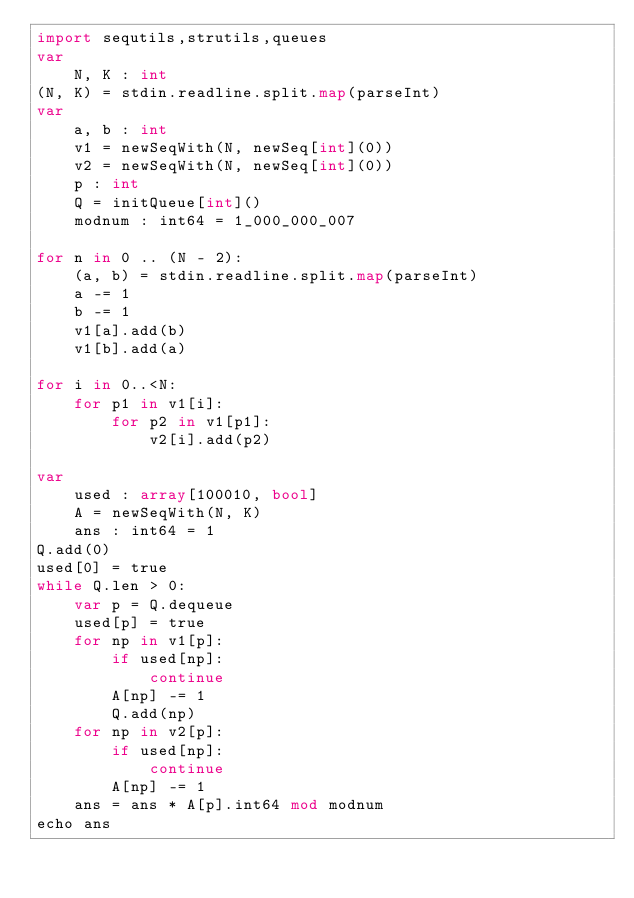Convert code to text. <code><loc_0><loc_0><loc_500><loc_500><_Nim_>import sequtils,strutils,queues
var
    N, K : int
(N, K) = stdin.readline.split.map(parseInt)
var
    a, b : int
    v1 = newSeqWith(N, newSeq[int](0))
    v2 = newSeqWith(N, newSeq[int](0))
    p : int
    Q = initQueue[int]()
    modnum : int64 = 1_000_000_007

for n in 0 .. (N - 2):
    (a, b) = stdin.readline.split.map(parseInt)
    a -= 1
    b -= 1
    v1[a].add(b)
    v1[b].add(a)

for i in 0..<N:
    for p1 in v1[i]:
        for p2 in v1[p1]:
            v2[i].add(p2)

var
    used : array[100010, bool]
    A = newSeqWith(N, K)
    ans : int64 = 1
Q.add(0)
used[0] = true
while Q.len > 0:
    var p = Q.dequeue
    used[p] = true
    for np in v1[p]:
        if used[np]:
            continue
        A[np] -= 1
        Q.add(np)
    for np in v2[p]:
        if used[np]:
            continue
        A[np] -= 1
    ans = ans * A[p].int64 mod modnum
echo ans


    </code> 